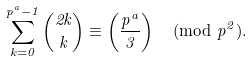Convert formula to latex. <formula><loc_0><loc_0><loc_500><loc_500>\sum _ { k = 0 } ^ { p ^ { a } - 1 } \binom { 2 k } { k } \equiv \left ( \frac { p ^ { a } } { 3 } \right ) \pmod { p ^ { 2 } } .</formula> 